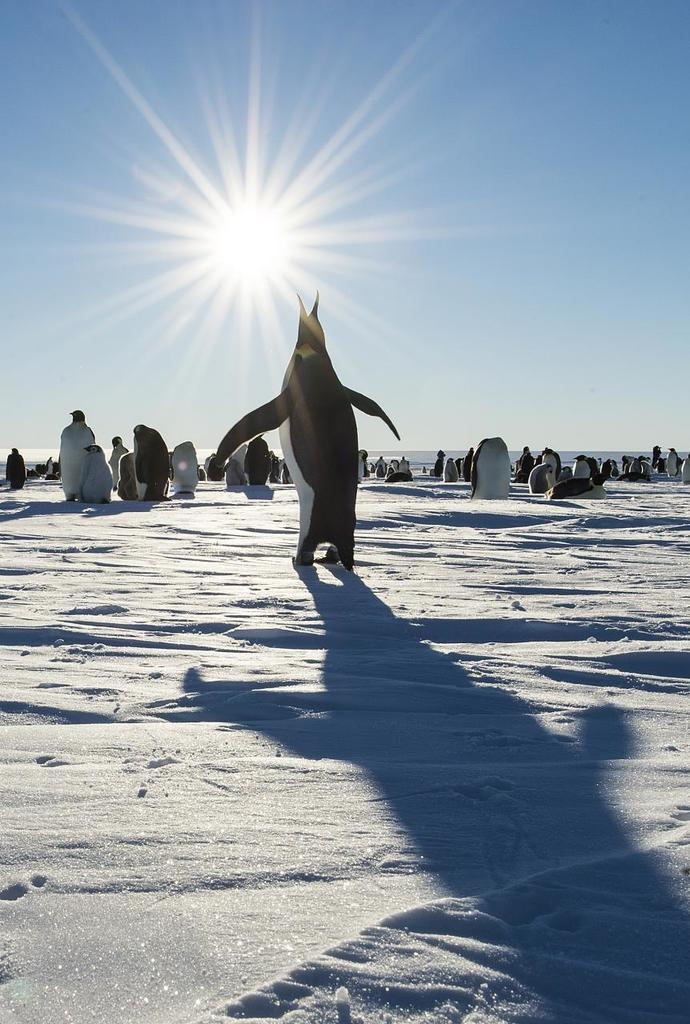What type of animals are in the image? There are penguins in the image. What is the surface on which the penguins are standing? The penguins are on snow. What can be seen in the background of the image? There is sky visible in the background of the image. What type of song is the penguin singing in the image? There is no indication in the image that the penguin is singing, and therefore no such song can be heard. 